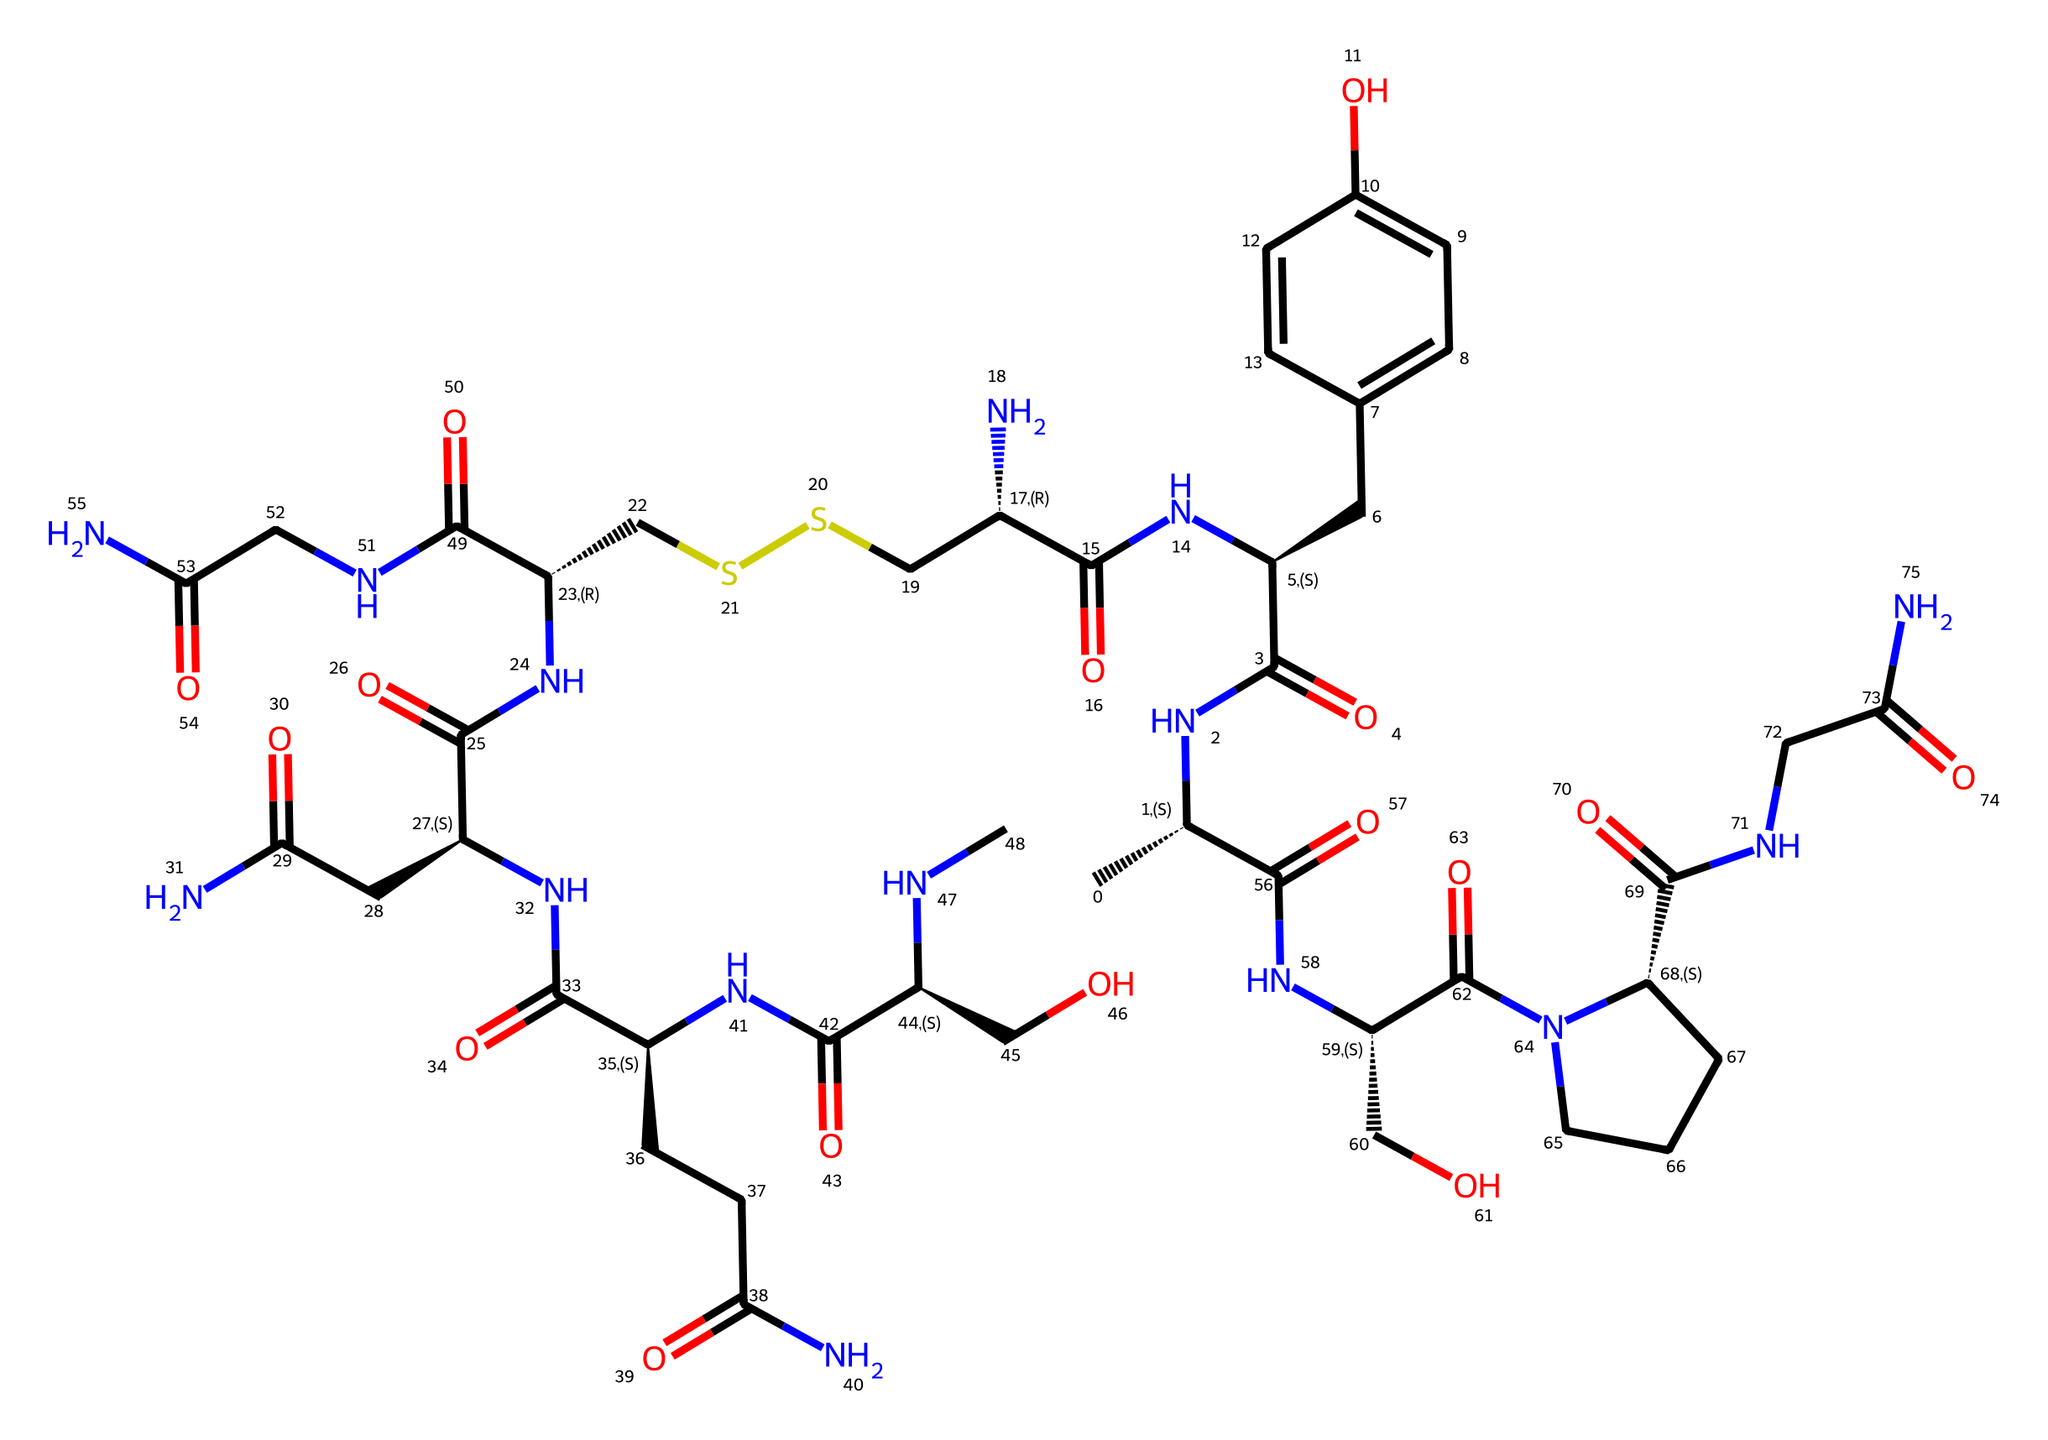What is the molecular formula of oxytocin? To find the molecular formula, count all the atoms of each element present in the SMILES representation. The SMILES contains 23 carbon atoms (C), 39 hydrogen atoms (H), 7 nitrogen atoms (N), 6 oxygen atoms (O), and 2 sulfur atoms (S). Therefore, the molecular formula is C43H66N12O12S2.
Answer: C43H66N12O12S2 How many nitrogen atoms are in the structure? By examining the SMILES representation, count the occurrences of the letter "N" which represents nitrogen. There are 7 occurrences of "N" in the chemical structure.
Answer: 7 What type of chemical bonds are predominantly present in oxytocin? The SMILES structure reveals multiple amide (C=O and N) and peptide bonds (C=O, N, and C), which are typical in hormones. These represent the primary types of bonds connecting the amino acids in the hormone.
Answer: amide bonds Which functional groups can be identified in the chemical? Analyzing the structure, functional groups like amides and thiols can be recognized. Amides are indicated by the C=O directly adjacent to an N, and thiols are indicated by –SH or –S in the structure.
Answer: amides, thiols What is the primary role of oxytocin in human behavior? Oxytocin plays a crucial role in social bonding and trust, notably during childbirth and lactation but also in general social interactions between individuals.
Answer: social bonding What does the presence of sulfur atoms suggest about the oxytocin structure? The presence of sulfur atoms suggests the involvement of disulfide bridges, which contribute to the stability and 3D conformation of the hormone. These are essential for the proper functional activity of oxytocin.
Answer: disulfide bridges How many total rings are present in the oxytocin structure? A careful analysis of the SMILES representation shows one cyclic structure, indicated by the "C(...)" formatting. This indicates one cyclic component in the overall structure.
Answer: 1 